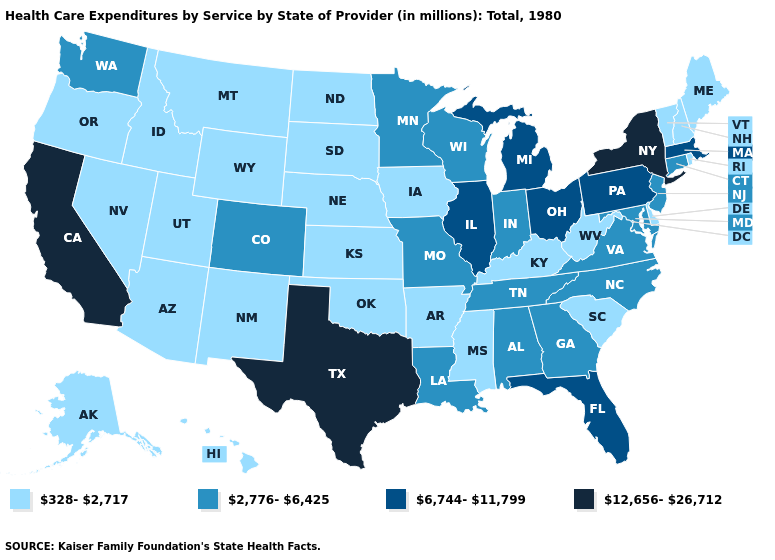Name the states that have a value in the range 328-2,717?
Give a very brief answer. Alaska, Arizona, Arkansas, Delaware, Hawaii, Idaho, Iowa, Kansas, Kentucky, Maine, Mississippi, Montana, Nebraska, Nevada, New Hampshire, New Mexico, North Dakota, Oklahoma, Oregon, Rhode Island, South Carolina, South Dakota, Utah, Vermont, West Virginia, Wyoming. Name the states that have a value in the range 2,776-6,425?
Concise answer only. Alabama, Colorado, Connecticut, Georgia, Indiana, Louisiana, Maryland, Minnesota, Missouri, New Jersey, North Carolina, Tennessee, Virginia, Washington, Wisconsin. What is the value of Oregon?
Give a very brief answer. 328-2,717. Does Iowa have a lower value than North Carolina?
Keep it brief. Yes. What is the highest value in the MidWest ?
Quick response, please. 6,744-11,799. Among the states that border New York , does Vermont have the lowest value?
Concise answer only. Yes. Name the states that have a value in the range 328-2,717?
Be succinct. Alaska, Arizona, Arkansas, Delaware, Hawaii, Idaho, Iowa, Kansas, Kentucky, Maine, Mississippi, Montana, Nebraska, Nevada, New Hampshire, New Mexico, North Dakota, Oklahoma, Oregon, Rhode Island, South Carolina, South Dakota, Utah, Vermont, West Virginia, Wyoming. Does the map have missing data?
Give a very brief answer. No. What is the value of Massachusetts?
Short answer required. 6,744-11,799. What is the value of Texas?
Keep it brief. 12,656-26,712. Does West Virginia have a higher value than New Hampshire?
Answer briefly. No. Does the first symbol in the legend represent the smallest category?
Write a very short answer. Yes. Name the states that have a value in the range 328-2,717?
Answer briefly. Alaska, Arizona, Arkansas, Delaware, Hawaii, Idaho, Iowa, Kansas, Kentucky, Maine, Mississippi, Montana, Nebraska, Nevada, New Hampshire, New Mexico, North Dakota, Oklahoma, Oregon, Rhode Island, South Carolina, South Dakota, Utah, Vermont, West Virginia, Wyoming. Does New York have the highest value in the USA?
Keep it brief. Yes. Name the states that have a value in the range 2,776-6,425?
Answer briefly. Alabama, Colorado, Connecticut, Georgia, Indiana, Louisiana, Maryland, Minnesota, Missouri, New Jersey, North Carolina, Tennessee, Virginia, Washington, Wisconsin. 